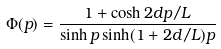<formula> <loc_0><loc_0><loc_500><loc_500>\Phi ( p ) = \frac { 1 + \cosh 2 d p / L } { \sinh p \sinh ( 1 + 2 d / L ) p }</formula> 